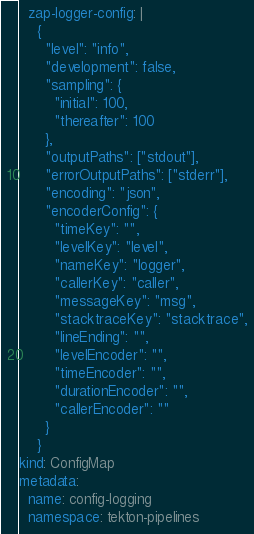<code> <loc_0><loc_0><loc_500><loc_500><_YAML_>  zap-logger-config: |
    {
      "level": "info",
      "development": false,
      "sampling": {
        "initial": 100,
        "thereafter": 100
      },
      "outputPaths": ["stdout"],
      "errorOutputPaths": ["stderr"],
      "encoding": "json",
      "encoderConfig": {
        "timeKey": "",
        "levelKey": "level",
        "nameKey": "logger",
        "callerKey": "caller",
        "messageKey": "msg",
        "stacktraceKey": "stacktrace",
        "lineEnding": "",
        "levelEncoder": "",
        "timeEncoder": "",
        "durationEncoder": "",
        "callerEncoder": ""
      }
    }
kind: ConfigMap
metadata:
  name: config-logging
  namespace: tekton-pipelines
</code> 